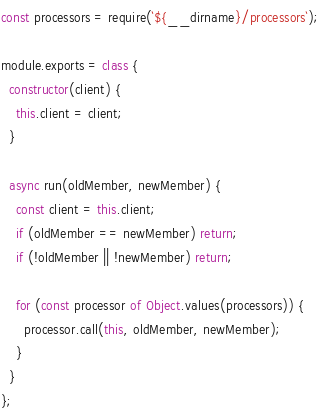Convert code to text. <code><loc_0><loc_0><loc_500><loc_500><_JavaScript_>const processors = require(`${__dirname}/processors`);

module.exports = class {
  constructor(client) {
    this.client = client;
  }

  async run(oldMember, newMember) {
    const client = this.client;
    if (oldMember == newMember) return;
    if (!oldMember || !newMember) return;
    
    for (const processor of Object.values(processors)) {
      processor.call(this, oldMember, newMember);
    }
  }
};
</code> 